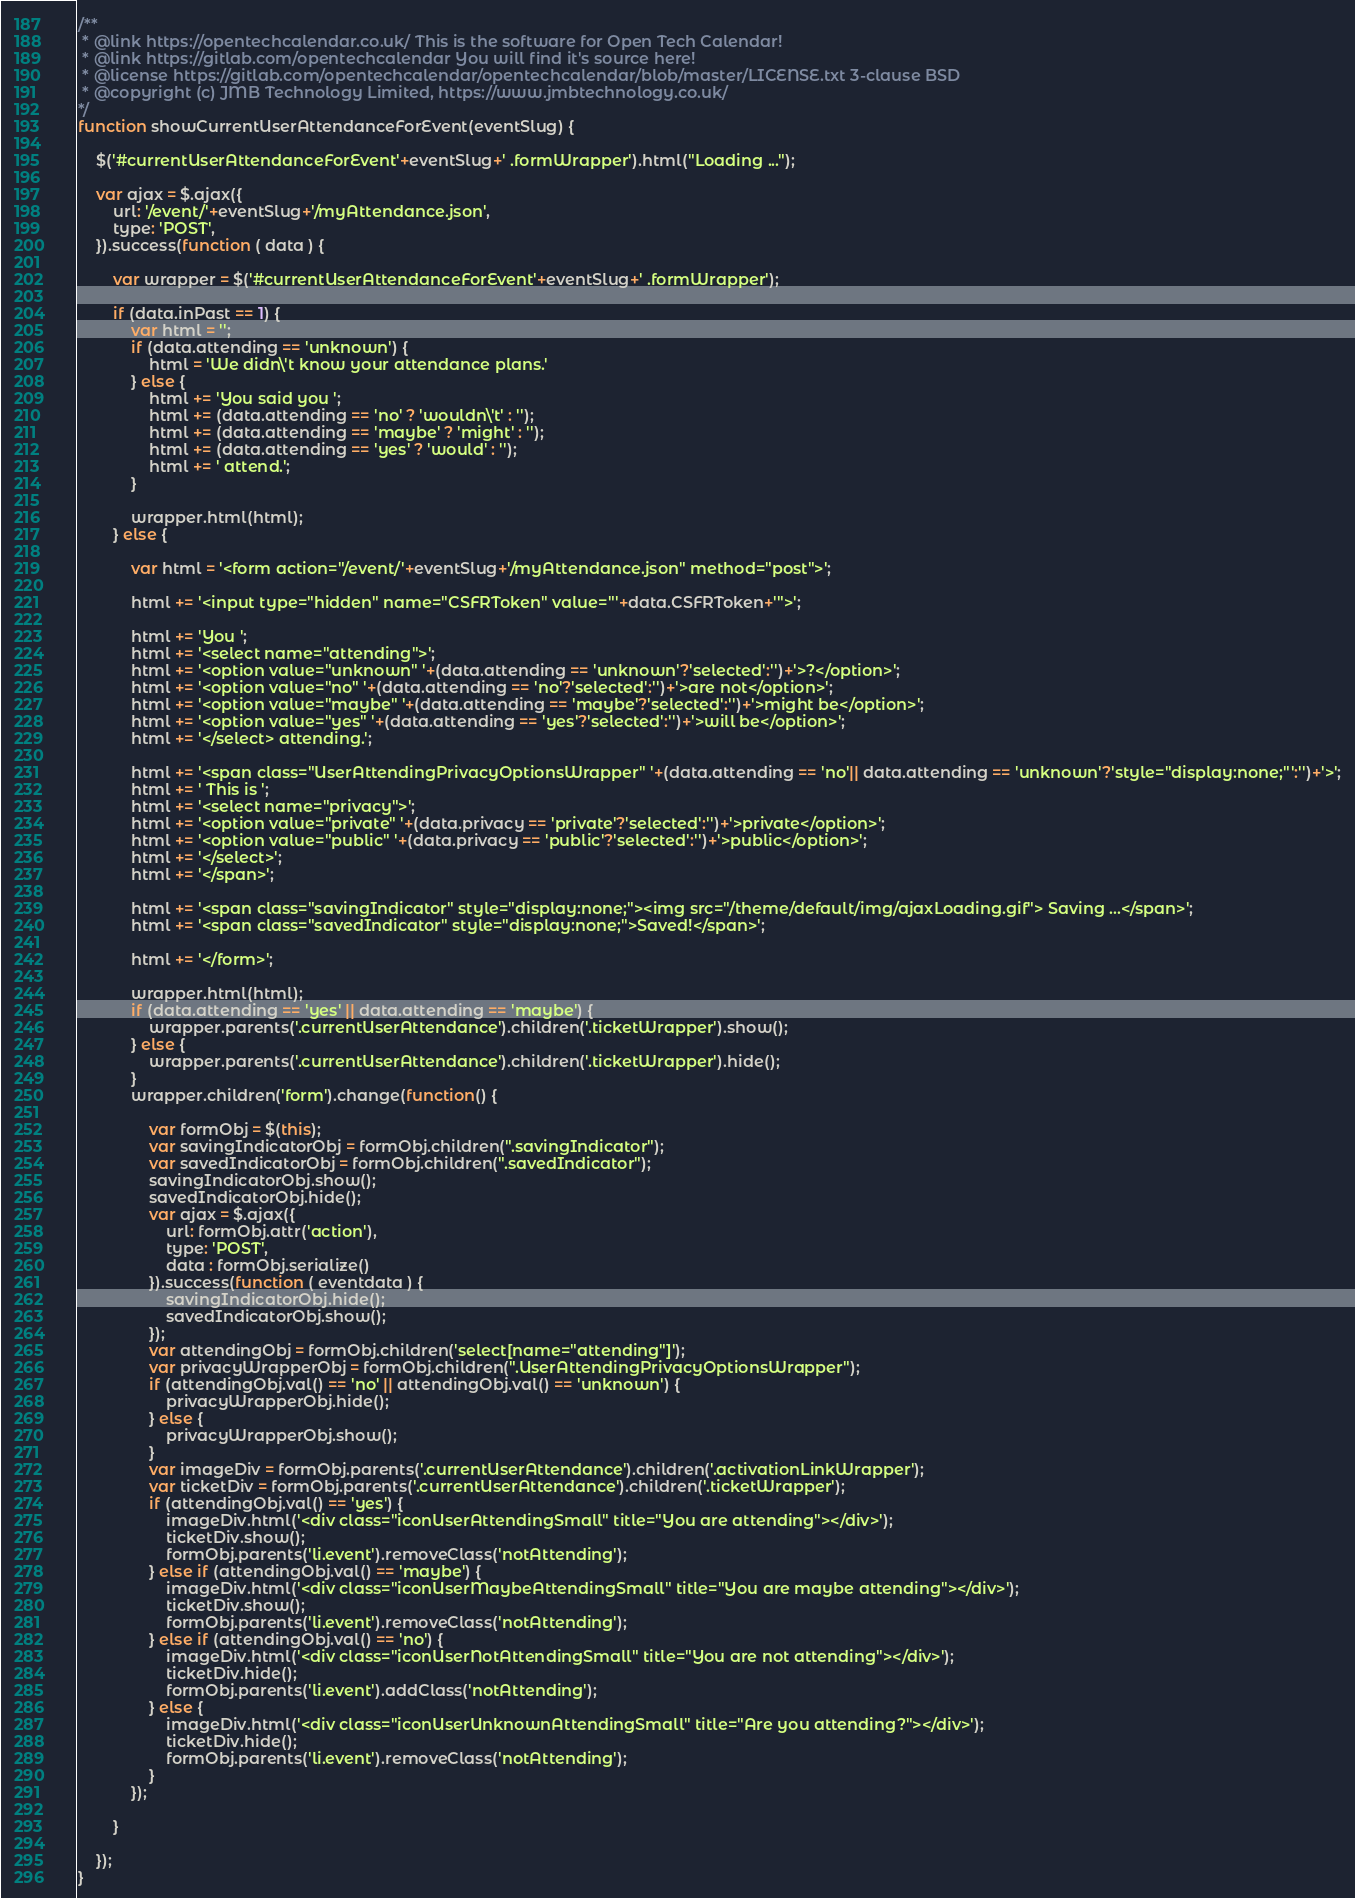Convert code to text. <code><loc_0><loc_0><loc_500><loc_500><_JavaScript_>/**
 * @link https://opentechcalendar.co.uk/ This is the software for Open Tech Calendar!
 * @link https://gitlab.com/opentechcalendar You will find it's source here!
 * @license https://gitlab.com/opentechcalendar/opentechcalendar/blob/master/LICENSE.txt 3-clause BSD
 * @copyright (c) JMB Technology Limited, https://www.jmbtechnology.co.uk/
*/
function showCurrentUserAttendanceForEvent(eventSlug) {

	$('#currentUserAttendanceForEvent'+eventSlug+' .formWrapper').html("Loading ...");
	
	var ajax = $.ajax({
		url: '/event/'+eventSlug+'/myAttendance.json',
		type: 'POST',
	}).success(function ( data ) {
		
		var wrapper = $('#currentUserAttendanceForEvent'+eventSlug+' .formWrapper');

		if (data.inPast == 1) {
			var html = '';
			if (data.attending == 'unknown') {
				html = 'We didn\'t know your attendance plans.'
			} else {
				html += 'You said you ';
				html += (data.attending == 'no' ? 'wouldn\'t' : '');
				html += (data.attending == 'maybe' ? 'might' : '');
				html += (data.attending == 'yes' ? 'would' : '');
				html += ' attend.';
			}
		
			wrapper.html(html);
		} else {
		
			var html = '<form action="/event/'+eventSlug+'/myAttendance.json" method="post">';

			html += '<input type="hidden" name="CSFRToken" value="'+data.CSFRToken+'">';

			html += 'You ';
			html += '<select name="attending">';
			html += '<option value="unknown" '+(data.attending == 'unknown'?'selected':'')+'>?</option>';
			html += '<option value="no" '+(data.attending == 'no'?'selected':'')+'>are not</option>';
			html += '<option value="maybe" '+(data.attending == 'maybe'?'selected':'')+'>might be</option>';
			html += '<option value="yes" '+(data.attending == 'yes'?'selected':'')+'>will be</option>';
			html += '</select> attending.';

			html += '<span class="UserAttendingPrivacyOptionsWrapper" '+(data.attending == 'no'|| data.attending == 'unknown'?'style="display:none;"':'')+'>';
			html += ' This is ';
			html += '<select name="privacy">';
			html += '<option value="private" '+(data.privacy == 'private'?'selected':'')+'>private</option>';
			html += '<option value="public" '+(data.privacy == 'public'?'selected':'')+'>public</option>';
			html += '</select>';
			html += '</span>';

			html += '<span class="savingIndicator" style="display:none;"><img src="/theme/default/img/ajaxLoading.gif"> Saving ...</span>';
			html += '<span class="savedIndicator" style="display:none;">Saved!</span>';

			html += '</form>';

			wrapper.html(html);
			if (data.attending == 'yes' || data.attending == 'maybe') {
				wrapper.parents('.currentUserAttendance').children('.ticketWrapper').show();
			} else {
				wrapper.parents('.currentUserAttendance').children('.ticketWrapper').hide();
			}
			wrapper.children('form').change(function() {

				var formObj = $(this);
				var savingIndicatorObj = formObj.children(".savingIndicator");
				var savedIndicatorObj = formObj.children(".savedIndicator");
				savingIndicatorObj.show();
				savedIndicatorObj.hide();
				var ajax = $.ajax({
					url: formObj.attr('action'),
					type: 'POST',
					data : formObj.serialize()
				}).success(function ( eventdata ) {
					savingIndicatorObj.hide();
					savedIndicatorObj.show();
				});
				var attendingObj = formObj.children('select[name="attending"]');
				var privacyWrapperObj = formObj.children(".UserAttendingPrivacyOptionsWrapper");
				if (attendingObj.val() == 'no' || attendingObj.val() == 'unknown') {
					privacyWrapperObj.hide();
				} else {
					privacyWrapperObj.show();
				}
				var imageDiv = formObj.parents('.currentUserAttendance').children('.activationLinkWrapper');
				var ticketDiv = formObj.parents('.currentUserAttendance').children('.ticketWrapper');
                if (attendingObj.val() == 'yes') {
                    imageDiv.html('<div class="iconUserAttendingSmall" title="You are attending"></div>');
                    ticketDiv.show();
                    formObj.parents('li.event').removeClass('notAttending');
                } else if (attendingObj.val() == 'maybe') {
                    imageDiv.html('<div class="iconUserMaybeAttendingSmall" title="You are maybe attending"></div>');
                    ticketDiv.show();
                    formObj.parents('li.event').removeClass('notAttending');
                } else if (attendingObj.val() == 'no') {
                    imageDiv.html('<div class="iconUserNotAttendingSmall" title="You are not attending"></div>');
                    ticketDiv.hide();
                    formObj.parents('li.event').addClass('notAttending');
                } else {
                    imageDiv.html('<div class="iconUserUnknownAttendingSmall" title="Are you attending?"></div>');
                    ticketDiv.hide();
                    formObj.parents('li.event').removeClass('notAttending');
                }
			});
		
		}
		
	});
}

</code> 